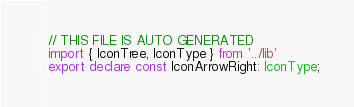<code> <loc_0><loc_0><loc_500><loc_500><_TypeScript_>// THIS FILE IS AUTO GENERATED
import { IconTree, IconType } from '../lib'
export declare const IconArrowRight: IconType;
</code> 